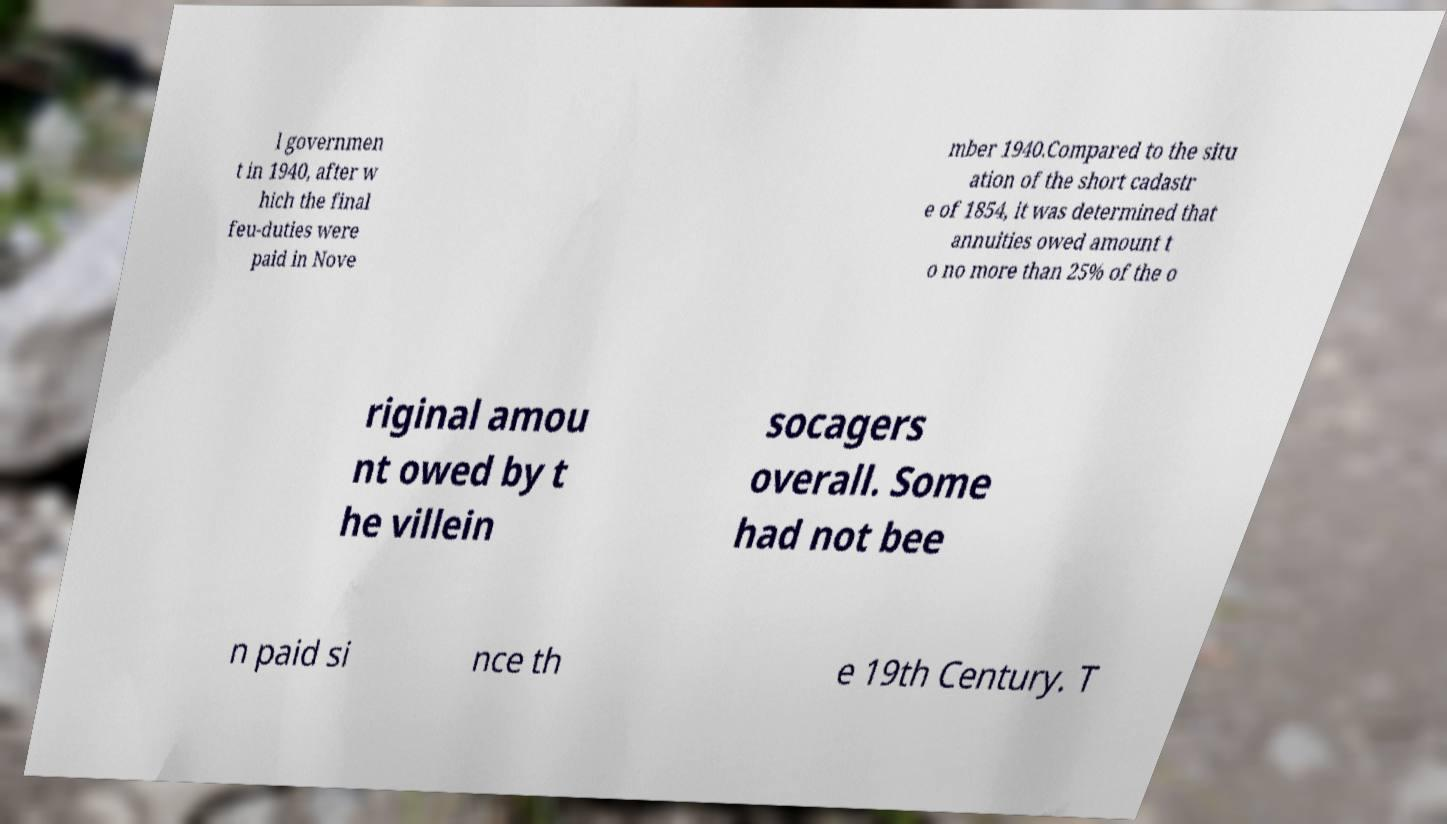Could you assist in decoding the text presented in this image and type it out clearly? l governmen t in 1940, after w hich the final feu-duties were paid in Nove mber 1940.Compared to the situ ation of the short cadastr e of 1854, it was determined that annuities owed amount t o no more than 25% of the o riginal amou nt owed by t he villein socagers overall. Some had not bee n paid si nce th e 19th Century. T 